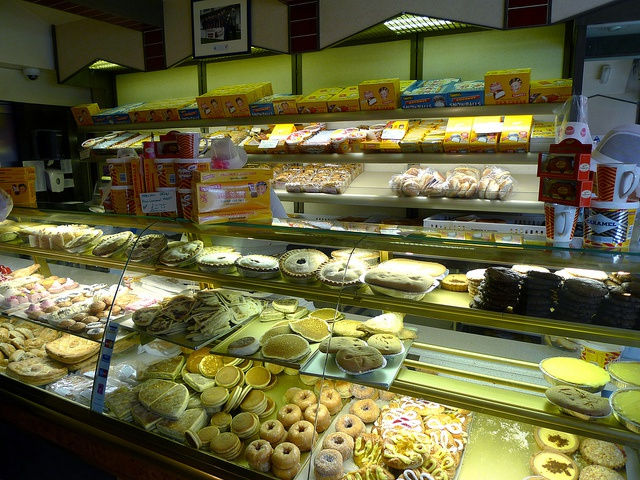Describe the objects in this image and their specific colors. I can see cake in black, beige, khaki, and olive tones, cup in black, maroon, and gray tones, cake in black, yellow, khaki, and olive tones, people in black, gray, and maroon tones, and cake in black, khaki, olive, and tan tones in this image. 